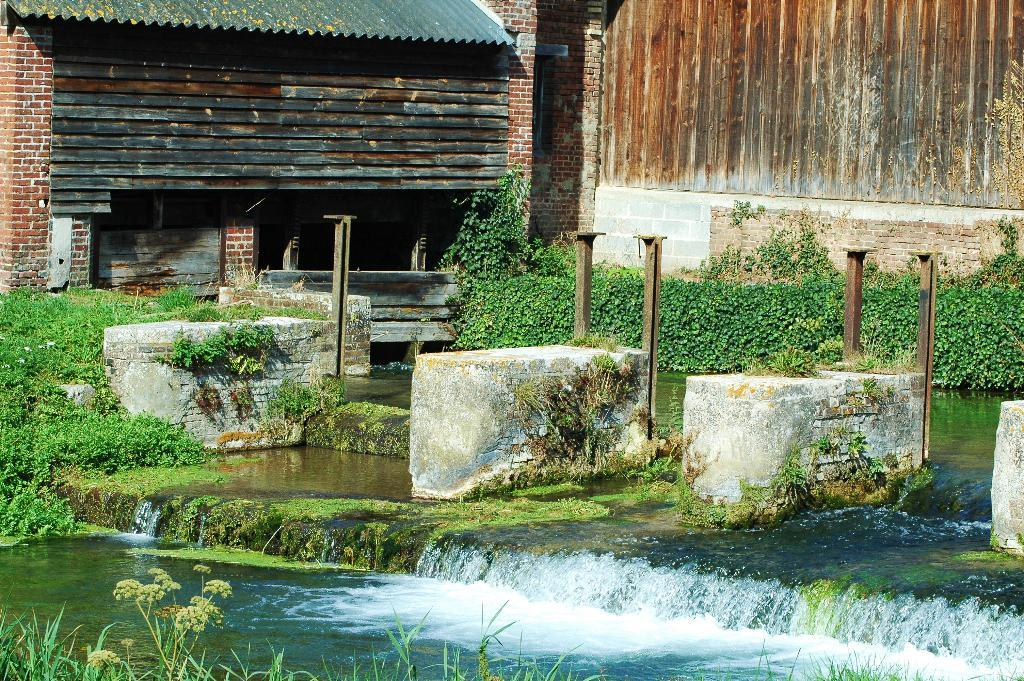What is present at the bottom of the image? There is water in the bottom of the image. What type of living organisms can be seen in the image? Plants are visible in the image. What can be seen in the background of the image? There is a wall in the background of the image. Can you hear the bell ringing in the image? There is no bell present in the image, so it cannot be heard. 